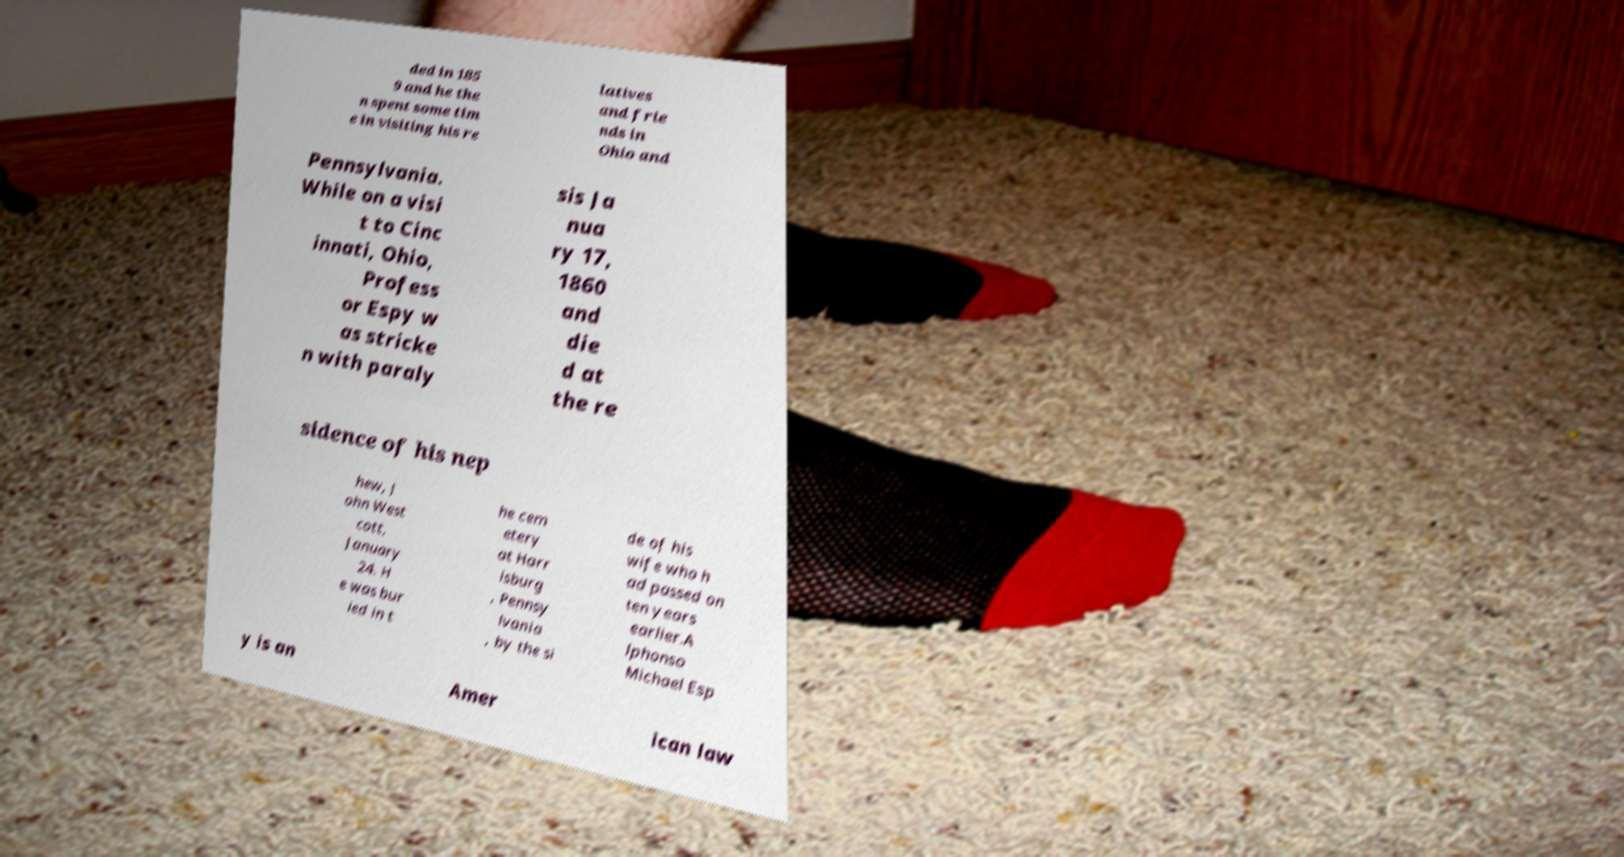For documentation purposes, I need the text within this image transcribed. Could you provide that? ded in 185 9 and he the n spent some tim e in visiting his re latives and frie nds in Ohio and Pennsylvania. While on a visi t to Cinc innati, Ohio, Profess or Espy w as stricke n with paraly sis Ja nua ry 17, 1860 and die d at the re sidence of his nep hew, J ohn West cott, January 24. H e was bur ied in t he cem etery at Harr isburg , Pennsy lvania , by the si de of his wife who h ad passed on ten years earlier.A lphonso Michael Esp y is an Amer ican law 